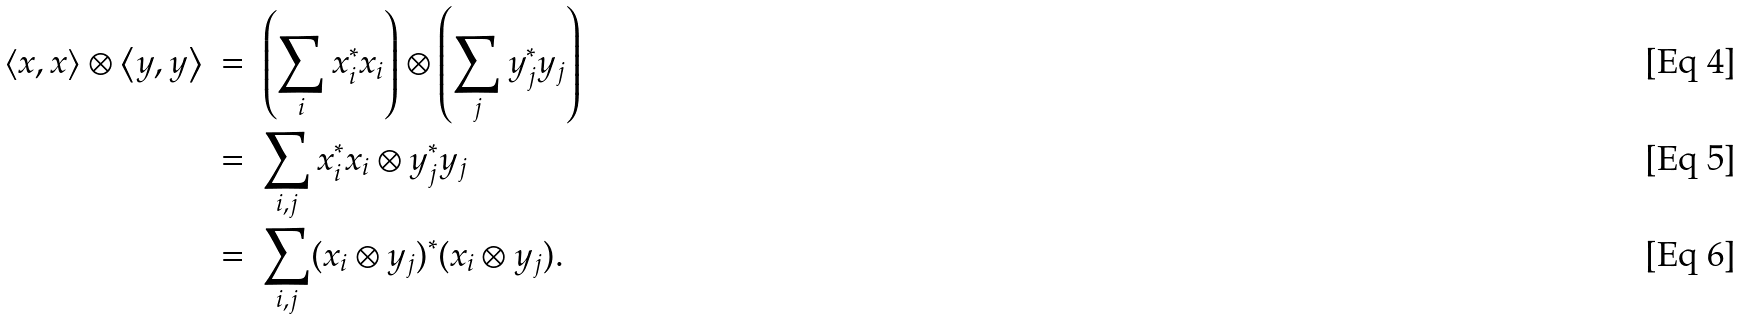Convert formula to latex. <formula><loc_0><loc_0><loc_500><loc_500>\left < x , x \right > \otimes \left < y , y \right > & \ = \ \left ( \sum _ { i } x _ { i } ^ { * } x _ { i } \right ) \otimes \left ( \sum _ { j } y _ { j } ^ { * } y _ { j } \right ) & \quad & \\ & \ = \ \sum _ { i , j } x _ { i } ^ { * } x _ { i } \otimes y _ { j } ^ { * } y _ { j } \\ & \ = \ \sum _ { i , j } ( x _ { i } \otimes y _ { j } ) ^ { * } ( x _ { i } \otimes y _ { j } ) .</formula> 